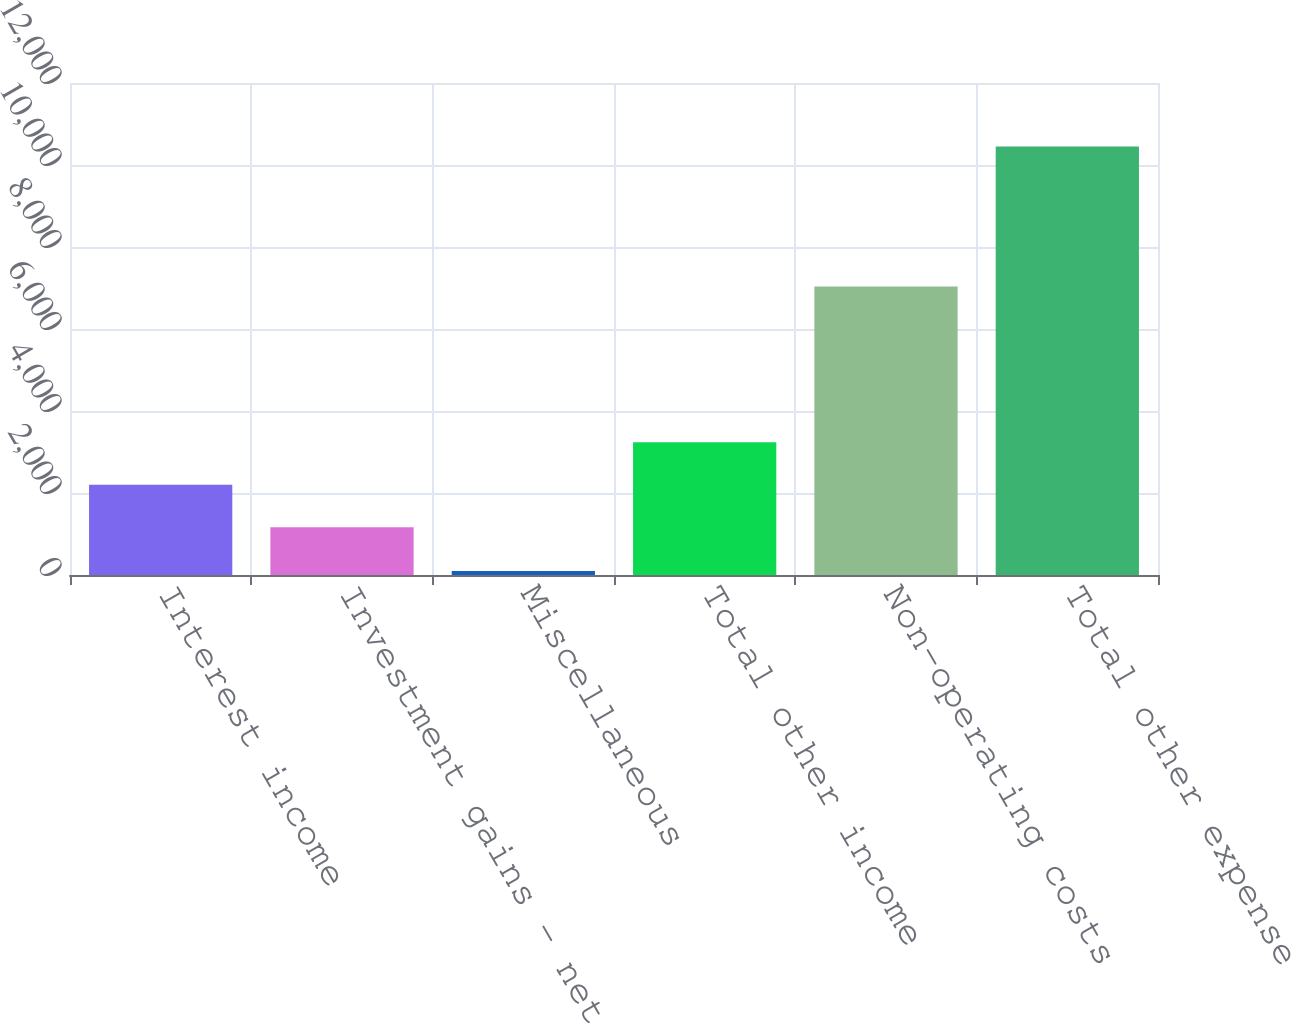Convert chart to OTSL. <chart><loc_0><loc_0><loc_500><loc_500><bar_chart><fcel>Interest income<fcel>Investment gains - net<fcel>Miscellaneous<fcel>Total other income<fcel>Non-operating costs<fcel>Total other expense<nl><fcel>2200.5<fcel>1165<fcel>96<fcel>3236<fcel>7037<fcel>10451<nl></chart> 